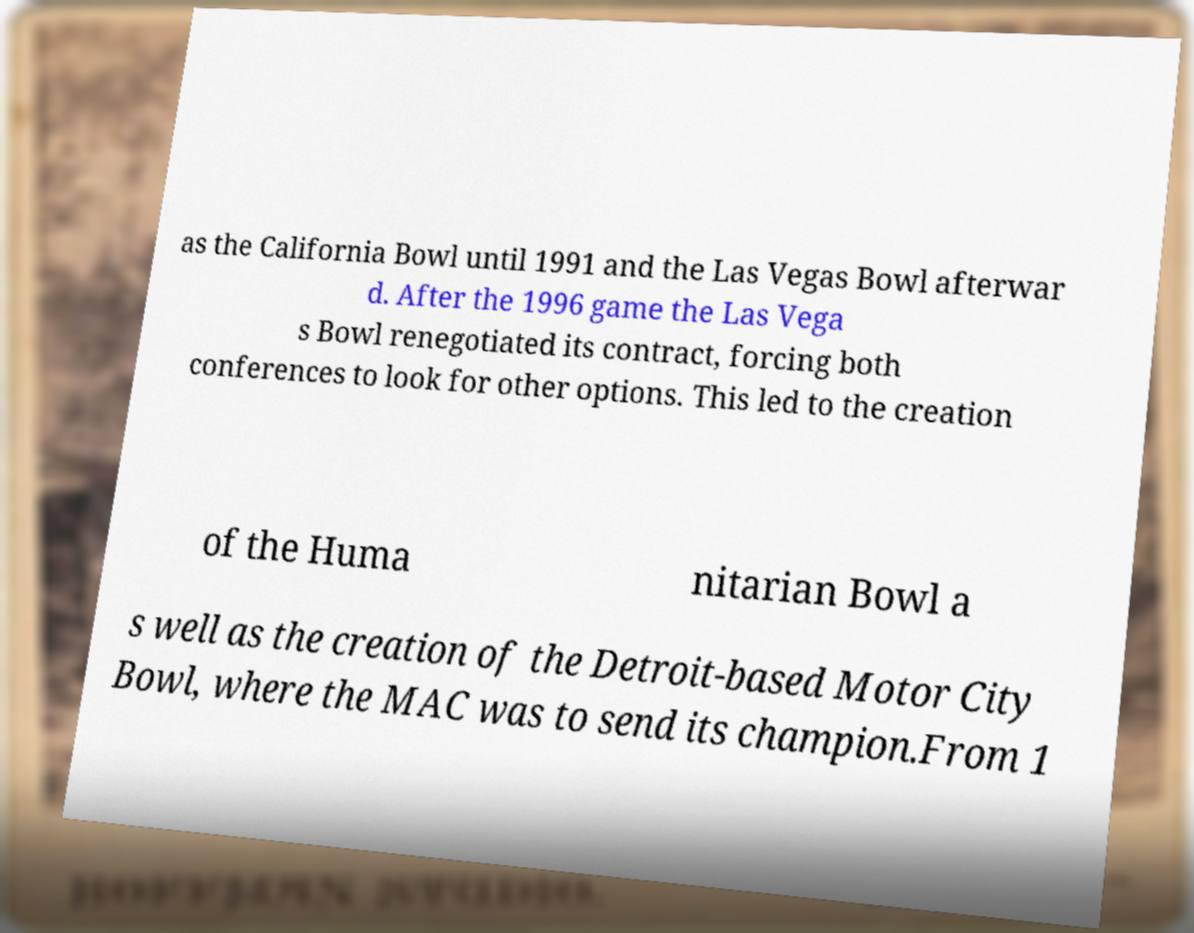What messages or text are displayed in this image? I need them in a readable, typed format. as the California Bowl until 1991 and the Las Vegas Bowl afterwar d. After the 1996 game the Las Vega s Bowl renegotiated its contract, forcing both conferences to look for other options. This led to the creation of the Huma nitarian Bowl a s well as the creation of the Detroit-based Motor City Bowl, where the MAC was to send its champion.From 1 